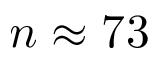<formula> <loc_0><loc_0><loc_500><loc_500>n \approx 7 3</formula> 